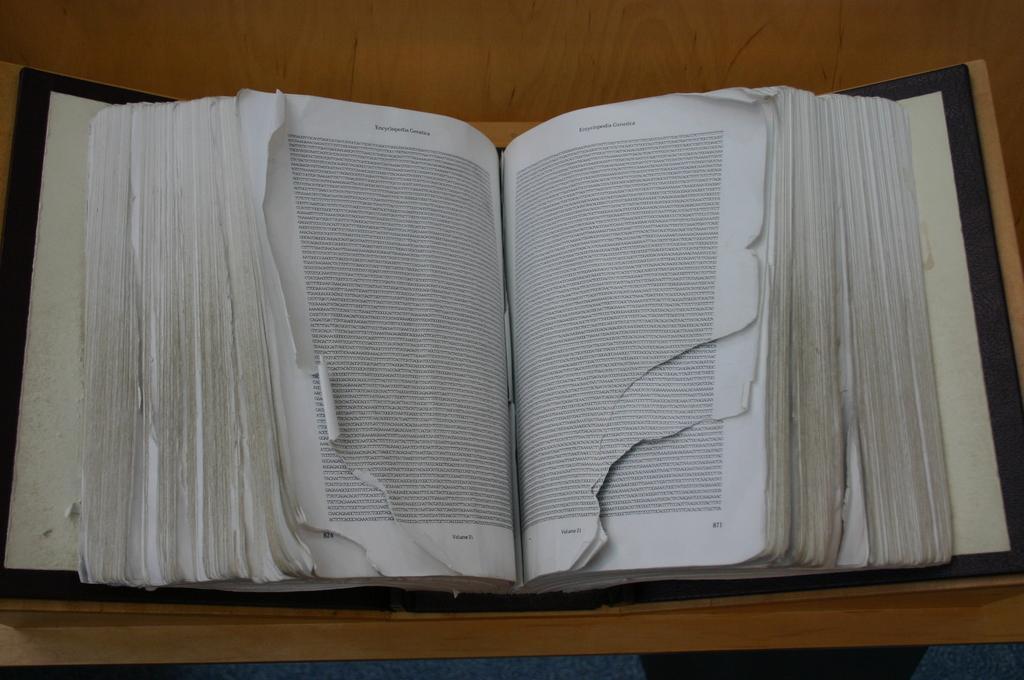Could you give a brief overview of what you see in this image? In this image we can see a book opened and placed on the table. 